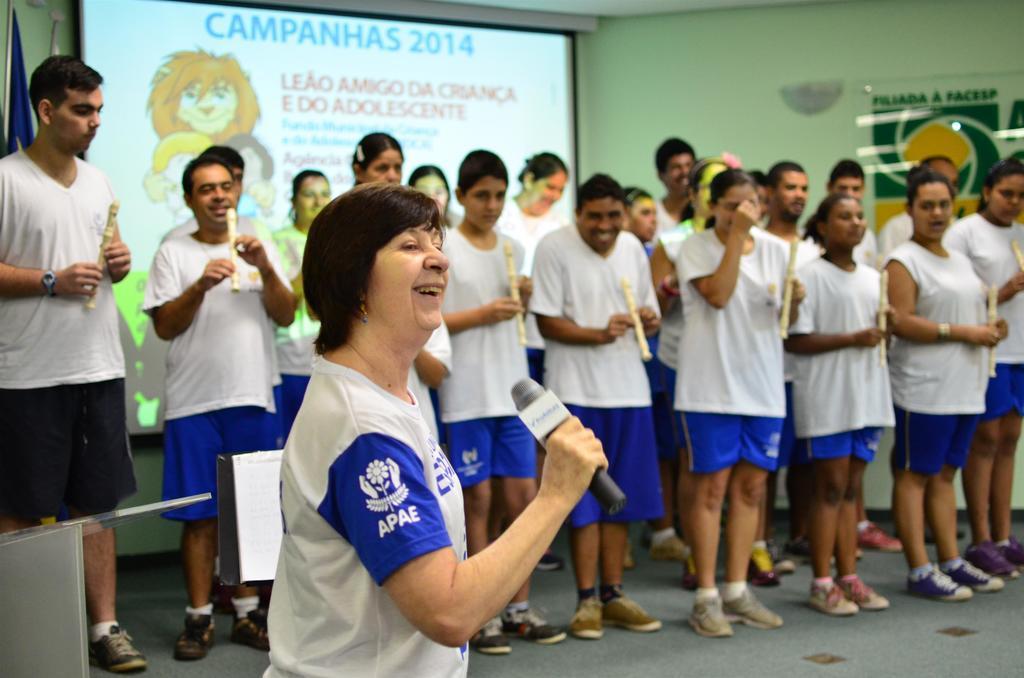Describe this image in one or two sentences. This image consists of many people wearing white T-shirts and shorts. In the front, the woman is holding a mic. In the background, all are holding the flutes. And we can see a projector screen along with a wall. On the left, we can see a flag. On the right, there is a glass board. 